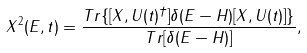<formula> <loc_0><loc_0><loc_500><loc_500>X ^ { 2 } ( E , t ) = \frac { T r \{ [ X , U ( t ) ^ { \dagger } ] \delta ( E - H ) [ X , U ( t ) ] \} } { T r [ \delta ( E - H ) ] } ,</formula> 